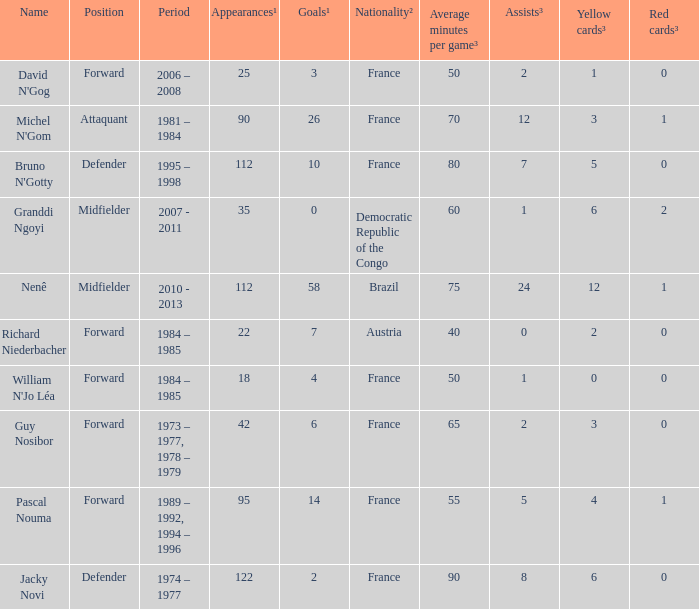List the player that scored 4 times. William N'Jo Léa. 